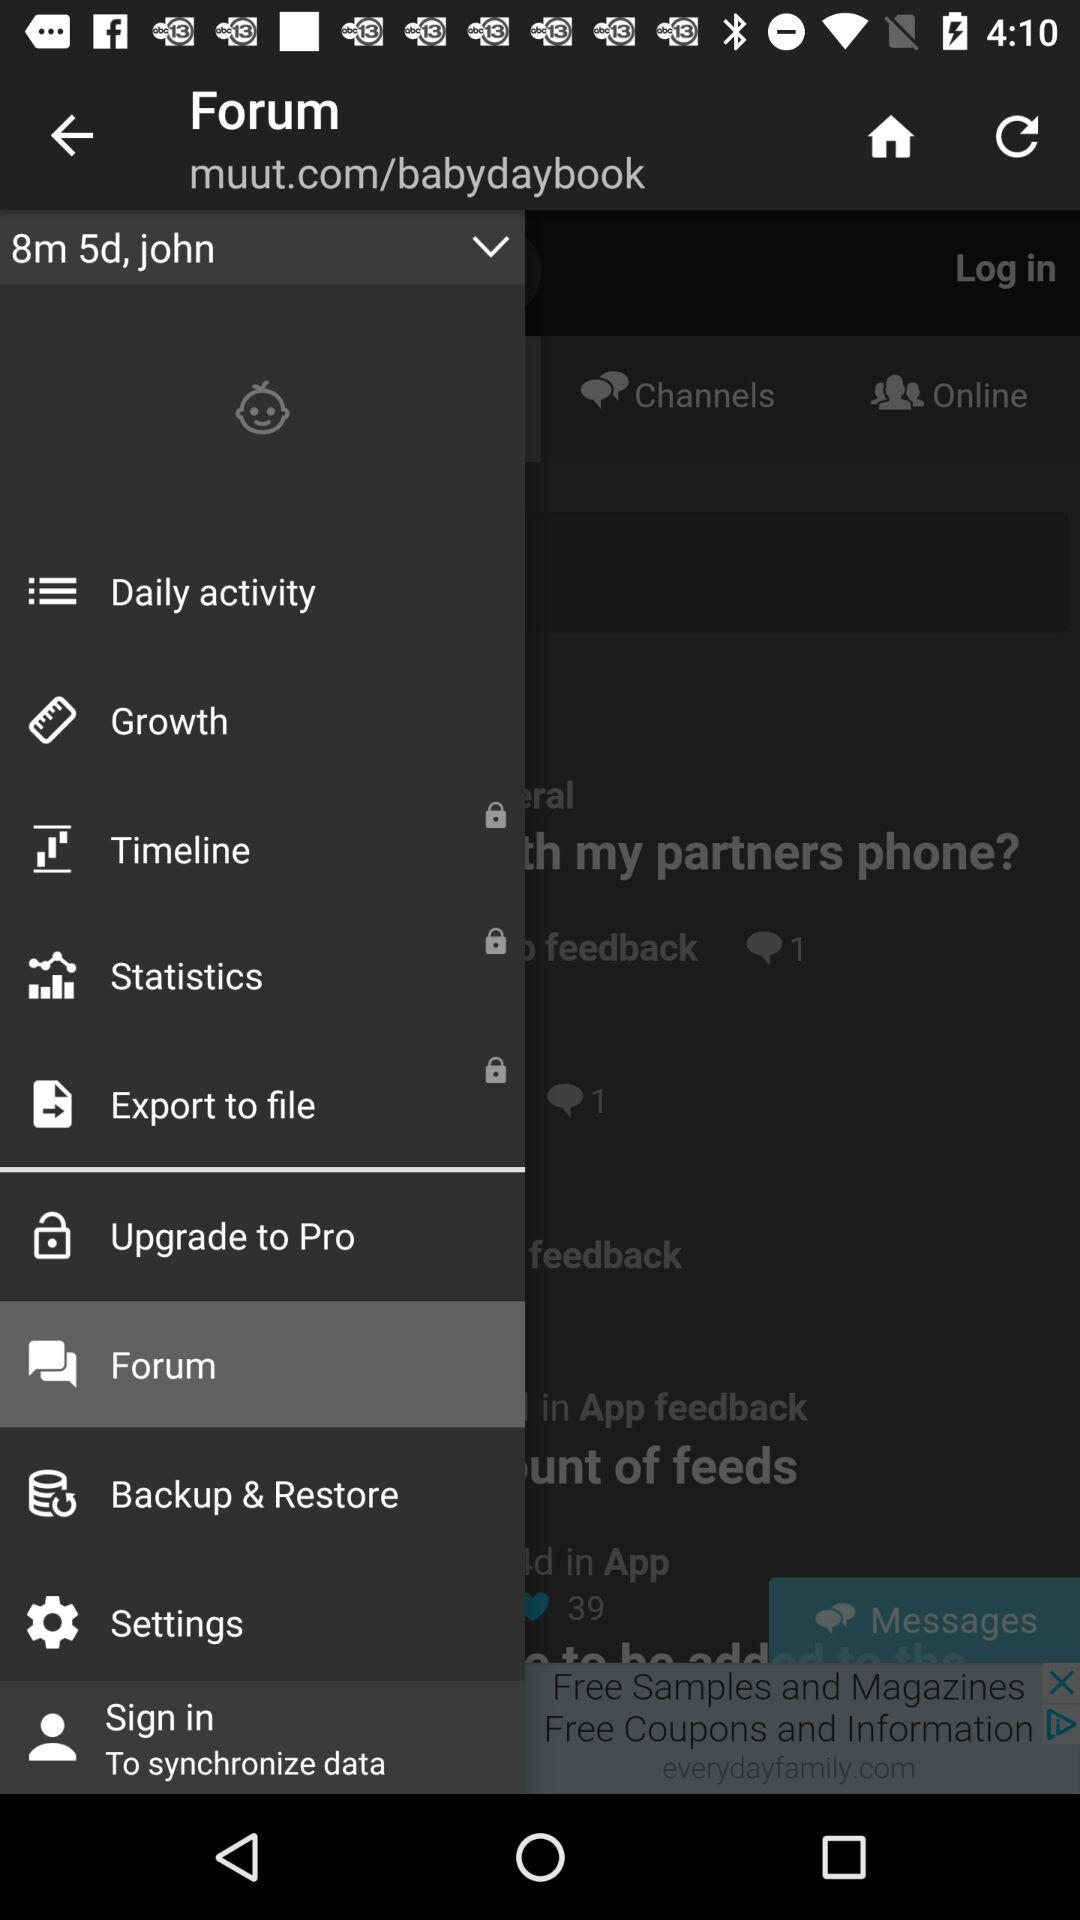Which item is selected? The selected item is "Forum". 